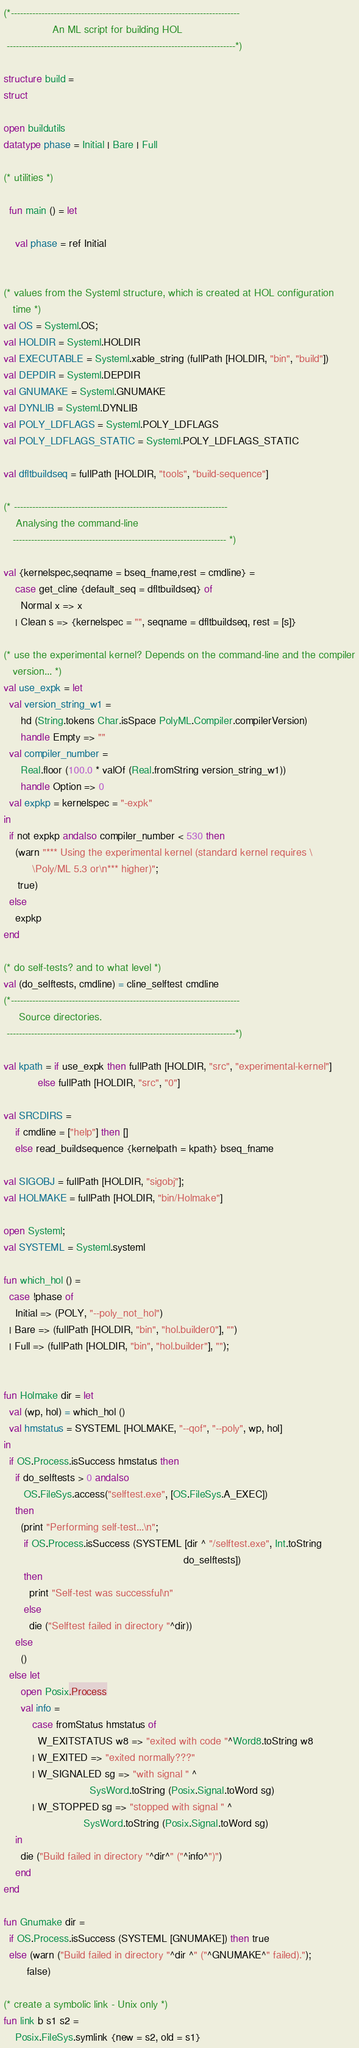Convert code to text. <code><loc_0><loc_0><loc_500><loc_500><_SML_>(*---------------------------------------------------------------------------
                An ML script for building HOL
 ---------------------------------------------------------------------------*)

structure build =
struct

open buildutils
datatype phase = Initial | Bare | Full

(* utilities *)

  fun main () = let

    val phase = ref Initial


(* values from the Systeml structure, which is created at HOL configuration
   time *)
val OS = Systeml.OS;
val HOLDIR = Systeml.HOLDIR
val EXECUTABLE = Systeml.xable_string (fullPath [HOLDIR, "bin", "build"])
val DEPDIR = Systeml.DEPDIR
val GNUMAKE = Systeml.GNUMAKE
val DYNLIB = Systeml.DYNLIB
val POLY_LDFLAGS = Systeml.POLY_LDFLAGS
val POLY_LDFLAGS_STATIC = Systeml.POLY_LDFLAGS_STATIC

val dfltbuildseq = fullPath [HOLDIR, "tools", "build-sequence"]

(* ----------------------------------------------------------------------
    Analysing the command-line
   ---------------------------------------------------------------------- *)

val {kernelspec,seqname = bseq_fname,rest = cmdline} =
    case get_cline {default_seq = dfltbuildseq} of
      Normal x => x
    | Clean s => {kernelspec = "", seqname = dfltbuildseq, rest = [s]}

(* use the experimental kernel? Depends on the command-line and the compiler
   version... *)
val use_expk = let
  val version_string_w1 =
      hd (String.tokens Char.isSpace PolyML.Compiler.compilerVersion)
      handle Empty => ""
  val compiler_number =
      Real.floor (100.0 * valOf (Real.fromString version_string_w1))
      handle Option => 0
  val expkp = kernelspec = "-expk"
in
  if not expkp andalso compiler_number < 530 then
    (warn "*** Using the experimental kernel (standard kernel requires \
          \Poly/ML 5.3 or\n*** higher)";
     true)
  else
    expkp
end

(* do self-tests? and to what level *)
val (do_selftests, cmdline) = cline_selftest cmdline
(*---------------------------------------------------------------------------
     Source directories.
 ---------------------------------------------------------------------------*)

val kpath = if use_expk then fullPath [HOLDIR, "src", "experimental-kernel"]
            else fullPath [HOLDIR, "src", "0"]

val SRCDIRS =
    if cmdline = ["help"] then []
    else read_buildsequence {kernelpath = kpath} bseq_fname

val SIGOBJ = fullPath [HOLDIR, "sigobj"];
val HOLMAKE = fullPath [HOLDIR, "bin/Holmake"]

open Systeml;
val SYSTEML = Systeml.systeml

fun which_hol () =
  case !phase of
    Initial => (POLY, "--poly_not_hol")
  | Bare => (fullPath [HOLDIR, "bin", "hol.builder0"], "")
  | Full => (fullPath [HOLDIR, "bin", "hol.builder"], "");


fun Holmake dir = let
  val (wp, hol) = which_hol ()
  val hmstatus = SYSTEML [HOLMAKE, "--qof", "--poly", wp, hol]
in
  if OS.Process.isSuccess hmstatus then
    if do_selftests > 0 andalso
       OS.FileSys.access("selftest.exe", [OS.FileSys.A_EXEC])
    then
      (print "Performing self-test...\n";
       if OS.Process.isSuccess (SYSTEML [dir ^ "/selftest.exe", Int.toString
                                                               do_selftests])
       then
         print "Self-test was successful\n"
       else
         die ("Selftest failed in directory "^dir))
    else
      ()
  else let
      open Posix.Process
      val info =
          case fromStatus hmstatus of
            W_EXITSTATUS w8 => "exited with code "^Word8.toString w8
          | W_EXITED => "exited normally???"
          | W_SIGNALED sg => "with signal " ^
                              SysWord.toString (Posix.Signal.toWord sg)
          | W_STOPPED sg => "stopped with signal " ^
                            SysWord.toString (Posix.Signal.toWord sg)
    in
      die ("Build failed in directory "^dir^" ("^info^")")
    end
end

fun Gnumake dir =
  if OS.Process.isSuccess (SYSTEML [GNUMAKE]) then true
  else (warn ("Build failed in directory "^dir ^" ("^GNUMAKE^" failed).");
        false)

(* create a symbolic link - Unix only *)
fun link b s1 s2 =
    Posix.FileSys.symlink {new = s2, old = s1}</code> 